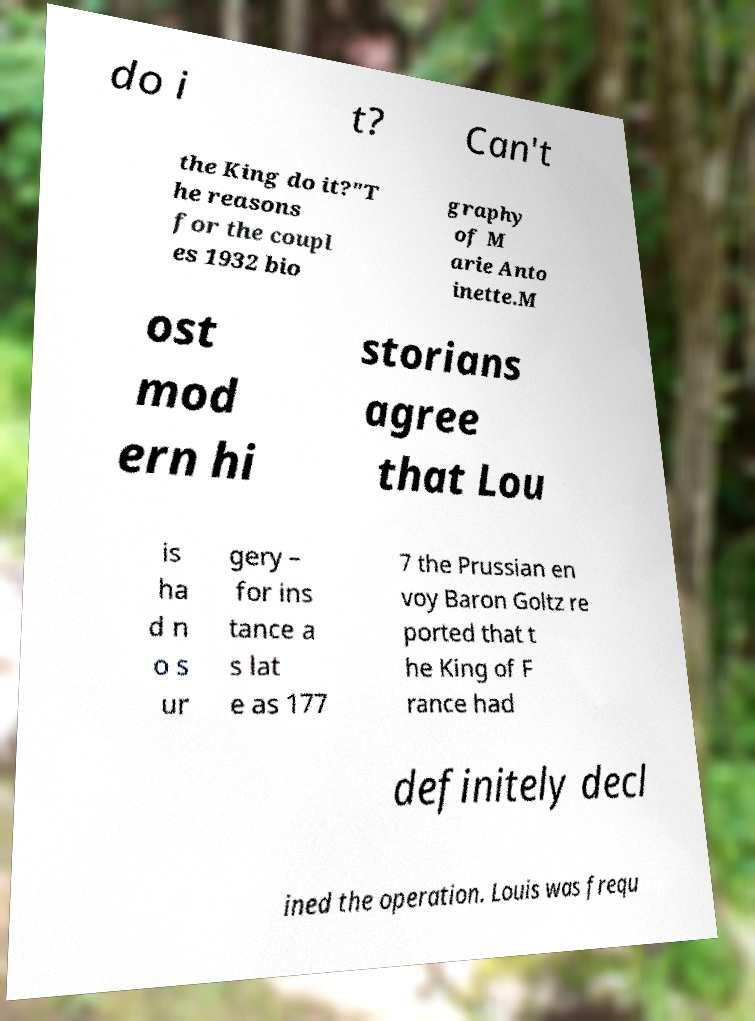Please identify and transcribe the text found in this image. do i t? Can't the King do it?"T he reasons for the coupl es 1932 bio graphy of M arie Anto inette.M ost mod ern hi storians agree that Lou is ha d n o s ur gery – for ins tance a s lat e as 177 7 the Prussian en voy Baron Goltz re ported that t he King of F rance had definitely decl ined the operation. Louis was frequ 